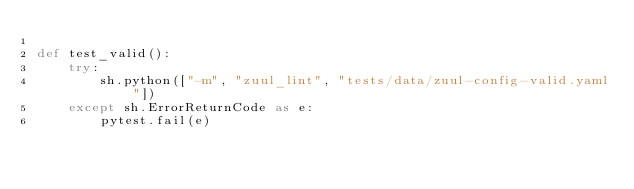<code> <loc_0><loc_0><loc_500><loc_500><_Python_>
def test_valid():
    try:
        sh.python(["-m", "zuul_lint", "tests/data/zuul-config-valid.yaml"])
    except sh.ErrorReturnCode as e:
        pytest.fail(e)
</code> 